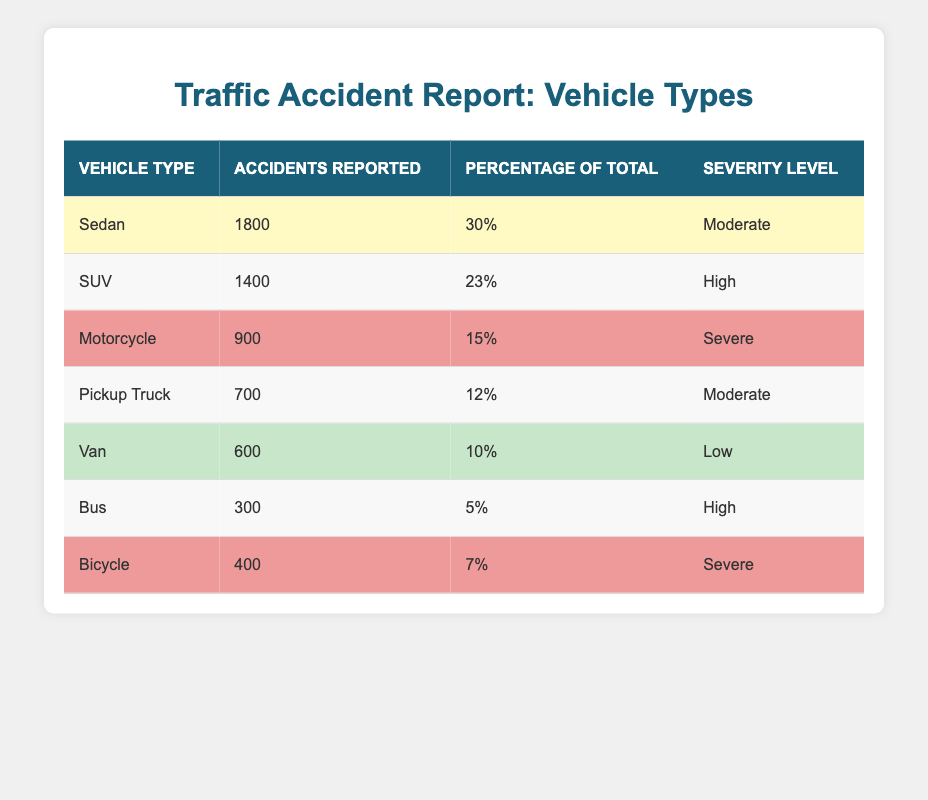What vehicle type had the highest number of reported accidents? The "Sedan" type had the highest number of reported accidents, showing 1800 accidents reported in the table.
Answer: Sedan What percentage of total accidents do SUVs account for? SUVs account for 23% of the total accidents reported in the table, as indicated under the "Percentage of Total" column.
Answer: 23% Which vehicle types have a severity level of "High"? The vehicle types with a severity level of "High" are "SUV" and "Bus", based on the data shown in the "Severity Level" column.
Answer: SUV, Bus What is the total number of accidents reported for motorcycles and bicycles combined? The total number of accidents reported for motorcycles (900) and bicycles (400) is calculated as 900 + 400 = 1300.
Answer: 1300 Is it true that the accidents reported for Vans are lower than those for Pickup Trucks? Yes, it is true as Vans reported 600 accidents while Pickup Trucks reported 700, making it lower.
Answer: Yes What is the average number of accidents reported across all vehicle types? To find the average, add all the reported accidents: 1800 + 1400 + 900 + 700 + 600 + 300 + 400 = 5100 accidents. Divide by the number of vehicle types, which is 7: 5100 / 7 = approximately 728.57.
Answer: 728.57 Which vehicle type is associated with the highest severity level? The "Motorcycle" and "SUV" types are associated with the highest severity levels, labeled as "Severe" and "High", respectively. However, "Motorcycle" is more severe.
Answer: Motorcycle How many more accidents were reported for Sedans compared to Buses? The difference in reported accidents is calculated as Sedans (1800) minus Buses (300), which equals 1500.
Answer: 1500 What percentage of the total accidents do Pickup Trucks and Vans account for together? To find this percentage, the calculations are as follows: Pickup Trucks account for 12% and Vans for 10%. Together, they equal 12% + 10% = 22%.
Answer: 22% 